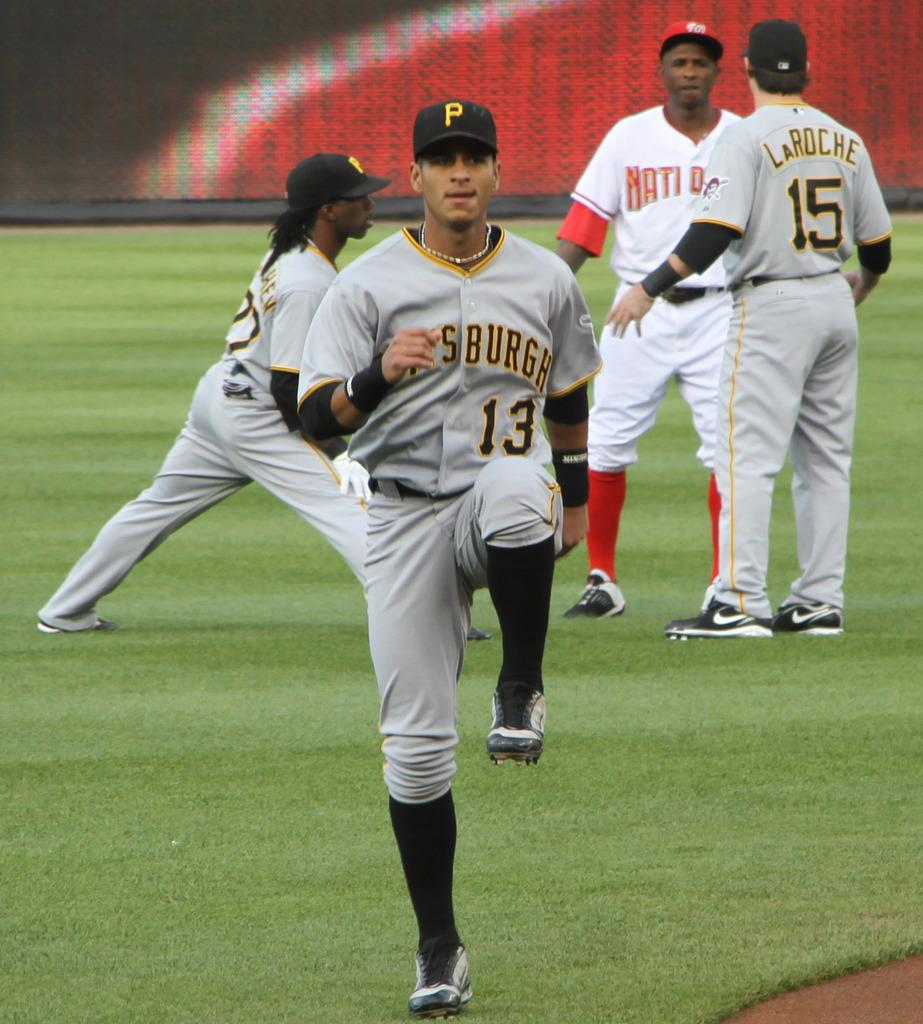<image>
Relay a brief, clear account of the picture shown. Two Pittsburgh baseball players warm up while LaRoche 15 talks to a Nationals player. 